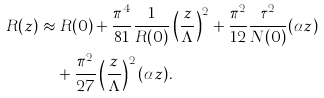Convert formula to latex. <formula><loc_0><loc_0><loc_500><loc_500>R ( z ) & \approx R ( 0 ) + \frac { \pi ^ { 4 } } { 8 1 } \frac { 1 } { R ( 0 ) } \left ( \frac { z } { \Lambda } \right ) ^ { 2 } + \frac { \pi ^ { 2 } } { 1 2 } \frac { \tau ^ { 2 } } { N ( 0 ) } ( \alpha z ) \\ & \quad + \frac { \pi ^ { 2 } } { 2 7 } \left ( \frac { z } { \Lambda } \right ) ^ { 2 } ( \alpha z ) .</formula> 